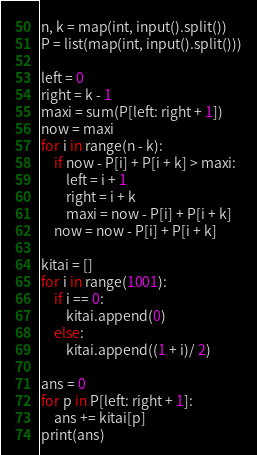Convert code to text. <code><loc_0><loc_0><loc_500><loc_500><_Python_>n, k = map(int, input().split())
P = list(map(int, input().split()))

left = 0
right = k - 1
maxi = sum(P[left: right + 1])
now = maxi
for i in range(n - k):
    if now - P[i] + P[i + k] > maxi:
        left = i + 1
        right = i + k
        maxi = now - P[i] + P[i + k]
    now = now - P[i] + P[i + k]

kitai = []
for i in range(1001):
    if i == 0:
        kitai.append(0)
    else:
        kitai.append((1 + i)/ 2)

ans = 0
for p in P[left: right + 1]:
    ans += kitai[p]
print(ans)</code> 